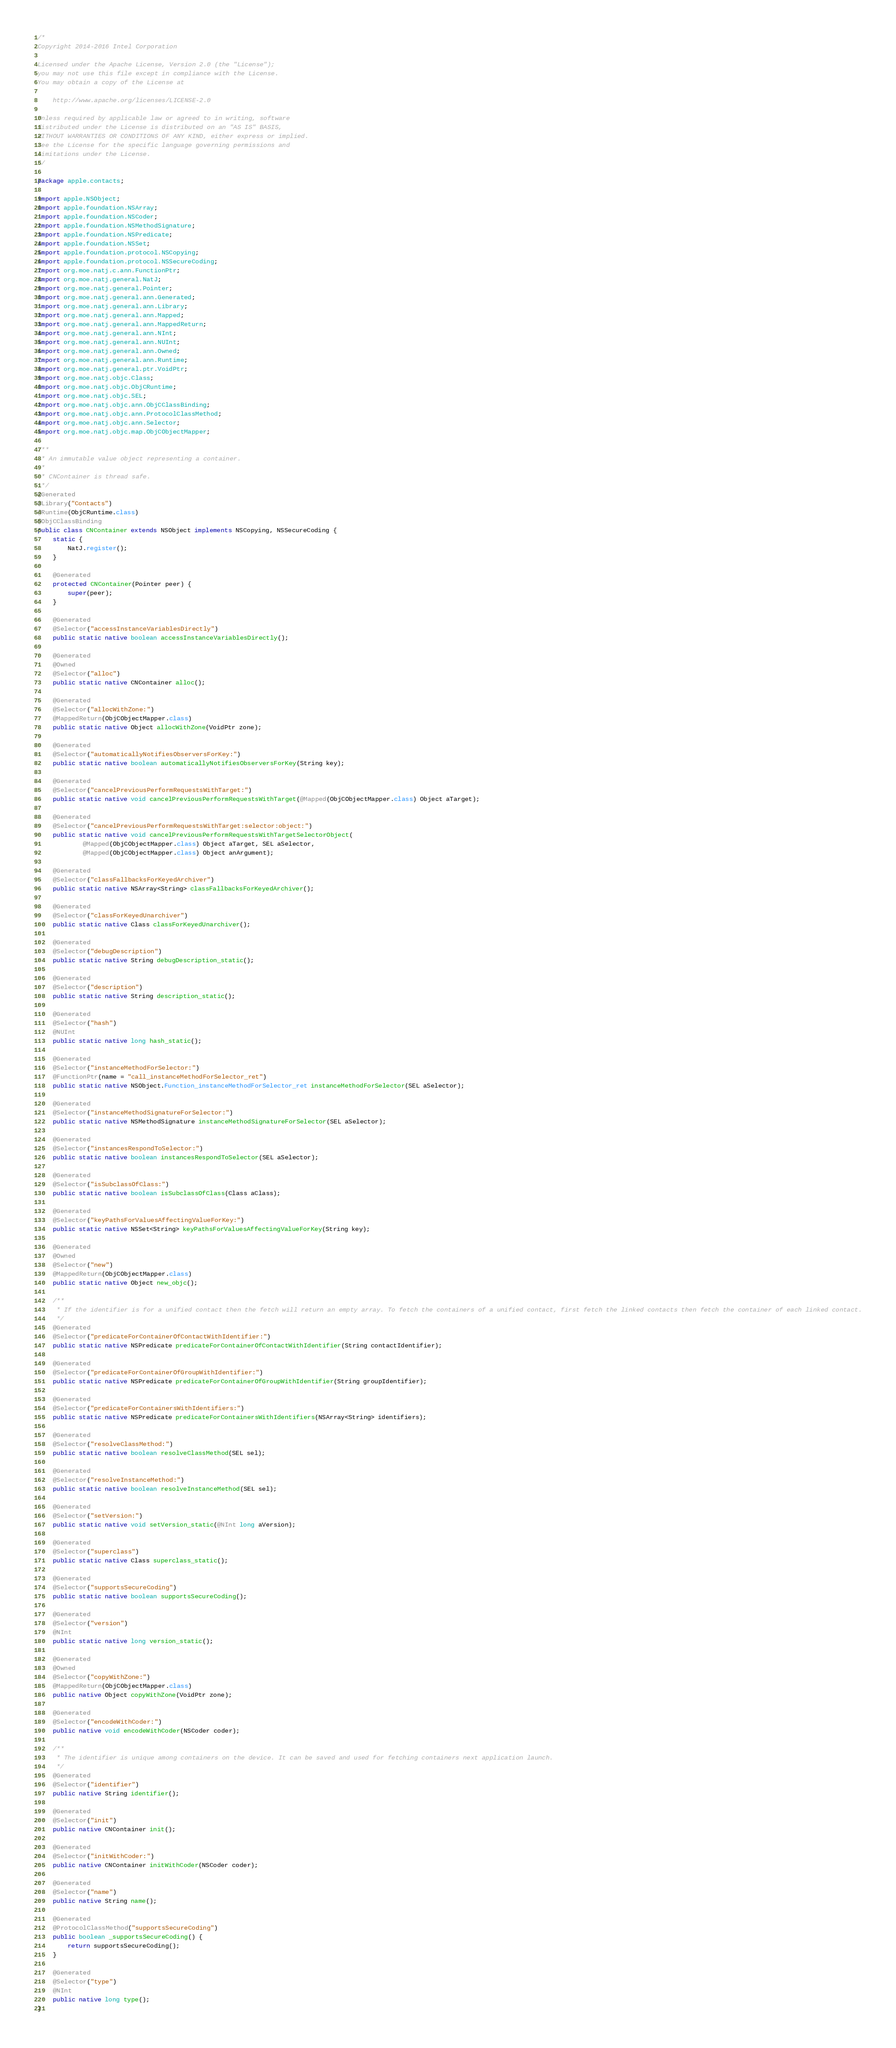Convert code to text. <code><loc_0><loc_0><loc_500><loc_500><_Java_>/*
Copyright 2014-2016 Intel Corporation

Licensed under the Apache License, Version 2.0 (the "License");
you may not use this file except in compliance with the License.
You may obtain a copy of the License at

    http://www.apache.org/licenses/LICENSE-2.0

Unless required by applicable law or agreed to in writing, software
distributed under the License is distributed on an "AS IS" BASIS,
WITHOUT WARRANTIES OR CONDITIONS OF ANY KIND, either express or implied.
See the License for the specific language governing permissions and
limitations under the License.
*/

package apple.contacts;

import apple.NSObject;
import apple.foundation.NSArray;
import apple.foundation.NSCoder;
import apple.foundation.NSMethodSignature;
import apple.foundation.NSPredicate;
import apple.foundation.NSSet;
import apple.foundation.protocol.NSCopying;
import apple.foundation.protocol.NSSecureCoding;
import org.moe.natj.c.ann.FunctionPtr;
import org.moe.natj.general.NatJ;
import org.moe.natj.general.Pointer;
import org.moe.natj.general.ann.Generated;
import org.moe.natj.general.ann.Library;
import org.moe.natj.general.ann.Mapped;
import org.moe.natj.general.ann.MappedReturn;
import org.moe.natj.general.ann.NInt;
import org.moe.natj.general.ann.NUInt;
import org.moe.natj.general.ann.Owned;
import org.moe.natj.general.ann.Runtime;
import org.moe.natj.general.ptr.VoidPtr;
import org.moe.natj.objc.Class;
import org.moe.natj.objc.ObjCRuntime;
import org.moe.natj.objc.SEL;
import org.moe.natj.objc.ann.ObjCClassBinding;
import org.moe.natj.objc.ann.ProtocolClassMethod;
import org.moe.natj.objc.ann.Selector;
import org.moe.natj.objc.map.ObjCObjectMapper;

/**
 * An immutable value object representing a container.
 * 
 * CNContainer is thread safe.
 */
@Generated
@Library("Contacts")
@Runtime(ObjCRuntime.class)
@ObjCClassBinding
public class CNContainer extends NSObject implements NSCopying, NSSecureCoding {
    static {
        NatJ.register();
    }

    @Generated
    protected CNContainer(Pointer peer) {
        super(peer);
    }

    @Generated
    @Selector("accessInstanceVariablesDirectly")
    public static native boolean accessInstanceVariablesDirectly();

    @Generated
    @Owned
    @Selector("alloc")
    public static native CNContainer alloc();

    @Generated
    @Selector("allocWithZone:")
    @MappedReturn(ObjCObjectMapper.class)
    public static native Object allocWithZone(VoidPtr zone);

    @Generated
    @Selector("automaticallyNotifiesObserversForKey:")
    public static native boolean automaticallyNotifiesObserversForKey(String key);

    @Generated
    @Selector("cancelPreviousPerformRequestsWithTarget:")
    public static native void cancelPreviousPerformRequestsWithTarget(@Mapped(ObjCObjectMapper.class) Object aTarget);

    @Generated
    @Selector("cancelPreviousPerformRequestsWithTarget:selector:object:")
    public static native void cancelPreviousPerformRequestsWithTargetSelectorObject(
            @Mapped(ObjCObjectMapper.class) Object aTarget, SEL aSelector,
            @Mapped(ObjCObjectMapper.class) Object anArgument);

    @Generated
    @Selector("classFallbacksForKeyedArchiver")
    public static native NSArray<String> classFallbacksForKeyedArchiver();

    @Generated
    @Selector("classForKeyedUnarchiver")
    public static native Class classForKeyedUnarchiver();

    @Generated
    @Selector("debugDescription")
    public static native String debugDescription_static();

    @Generated
    @Selector("description")
    public static native String description_static();

    @Generated
    @Selector("hash")
    @NUInt
    public static native long hash_static();

    @Generated
    @Selector("instanceMethodForSelector:")
    @FunctionPtr(name = "call_instanceMethodForSelector_ret")
    public static native NSObject.Function_instanceMethodForSelector_ret instanceMethodForSelector(SEL aSelector);

    @Generated
    @Selector("instanceMethodSignatureForSelector:")
    public static native NSMethodSignature instanceMethodSignatureForSelector(SEL aSelector);

    @Generated
    @Selector("instancesRespondToSelector:")
    public static native boolean instancesRespondToSelector(SEL aSelector);

    @Generated
    @Selector("isSubclassOfClass:")
    public static native boolean isSubclassOfClass(Class aClass);

    @Generated
    @Selector("keyPathsForValuesAffectingValueForKey:")
    public static native NSSet<String> keyPathsForValuesAffectingValueForKey(String key);

    @Generated
    @Owned
    @Selector("new")
    @MappedReturn(ObjCObjectMapper.class)
    public static native Object new_objc();

    /**
     * If the identifier is for a unified contact then the fetch will return an empty array. To fetch the containers of a unified contact, first fetch the linked contacts then fetch the container of each linked contact.
     */
    @Generated
    @Selector("predicateForContainerOfContactWithIdentifier:")
    public static native NSPredicate predicateForContainerOfContactWithIdentifier(String contactIdentifier);

    @Generated
    @Selector("predicateForContainerOfGroupWithIdentifier:")
    public static native NSPredicate predicateForContainerOfGroupWithIdentifier(String groupIdentifier);

    @Generated
    @Selector("predicateForContainersWithIdentifiers:")
    public static native NSPredicate predicateForContainersWithIdentifiers(NSArray<String> identifiers);

    @Generated
    @Selector("resolveClassMethod:")
    public static native boolean resolveClassMethod(SEL sel);

    @Generated
    @Selector("resolveInstanceMethod:")
    public static native boolean resolveInstanceMethod(SEL sel);

    @Generated
    @Selector("setVersion:")
    public static native void setVersion_static(@NInt long aVersion);

    @Generated
    @Selector("superclass")
    public static native Class superclass_static();

    @Generated
    @Selector("supportsSecureCoding")
    public static native boolean supportsSecureCoding();

    @Generated
    @Selector("version")
    @NInt
    public static native long version_static();

    @Generated
    @Owned
    @Selector("copyWithZone:")
    @MappedReturn(ObjCObjectMapper.class)
    public native Object copyWithZone(VoidPtr zone);

    @Generated
    @Selector("encodeWithCoder:")
    public native void encodeWithCoder(NSCoder coder);

    /**
     * The identifier is unique among containers on the device. It can be saved and used for fetching containers next application launch.
     */
    @Generated
    @Selector("identifier")
    public native String identifier();

    @Generated
    @Selector("init")
    public native CNContainer init();

    @Generated
    @Selector("initWithCoder:")
    public native CNContainer initWithCoder(NSCoder coder);

    @Generated
    @Selector("name")
    public native String name();

    @Generated
    @ProtocolClassMethod("supportsSecureCoding")
    public boolean _supportsSecureCoding() {
        return supportsSecureCoding();
    }

    @Generated
    @Selector("type")
    @NInt
    public native long type();
}
</code> 